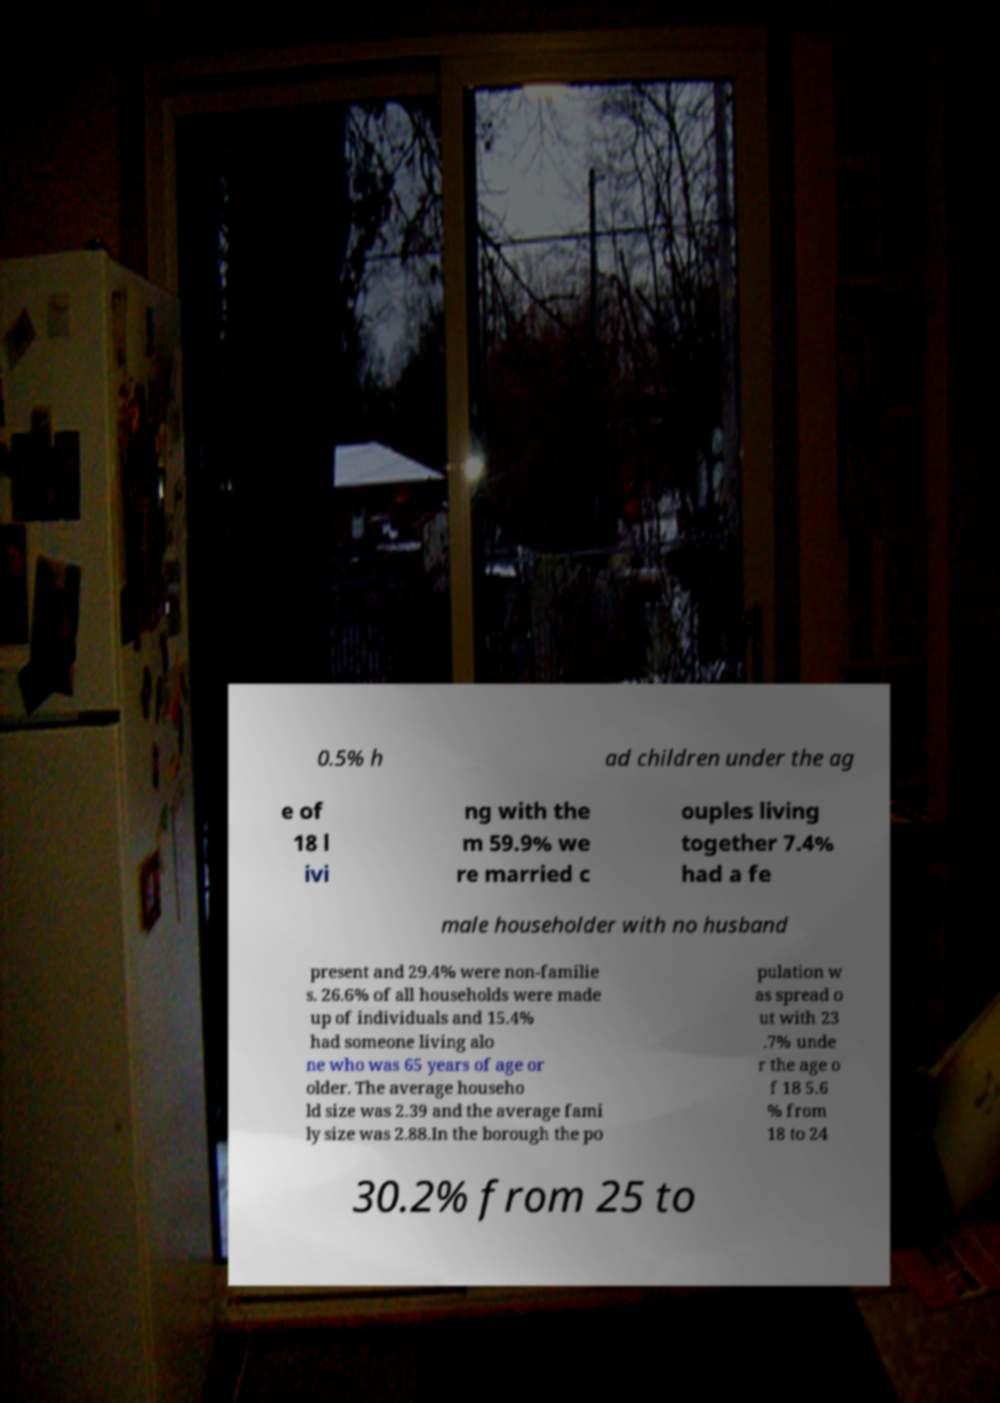Can you read and provide the text displayed in the image?This photo seems to have some interesting text. Can you extract and type it out for me? 0.5% h ad children under the ag e of 18 l ivi ng with the m 59.9% we re married c ouples living together 7.4% had a fe male householder with no husband present and 29.4% were non-familie s. 26.6% of all households were made up of individuals and 15.4% had someone living alo ne who was 65 years of age or older. The average househo ld size was 2.39 and the average fami ly size was 2.88.In the borough the po pulation w as spread o ut with 23 .7% unde r the age o f 18 5.6 % from 18 to 24 30.2% from 25 to 